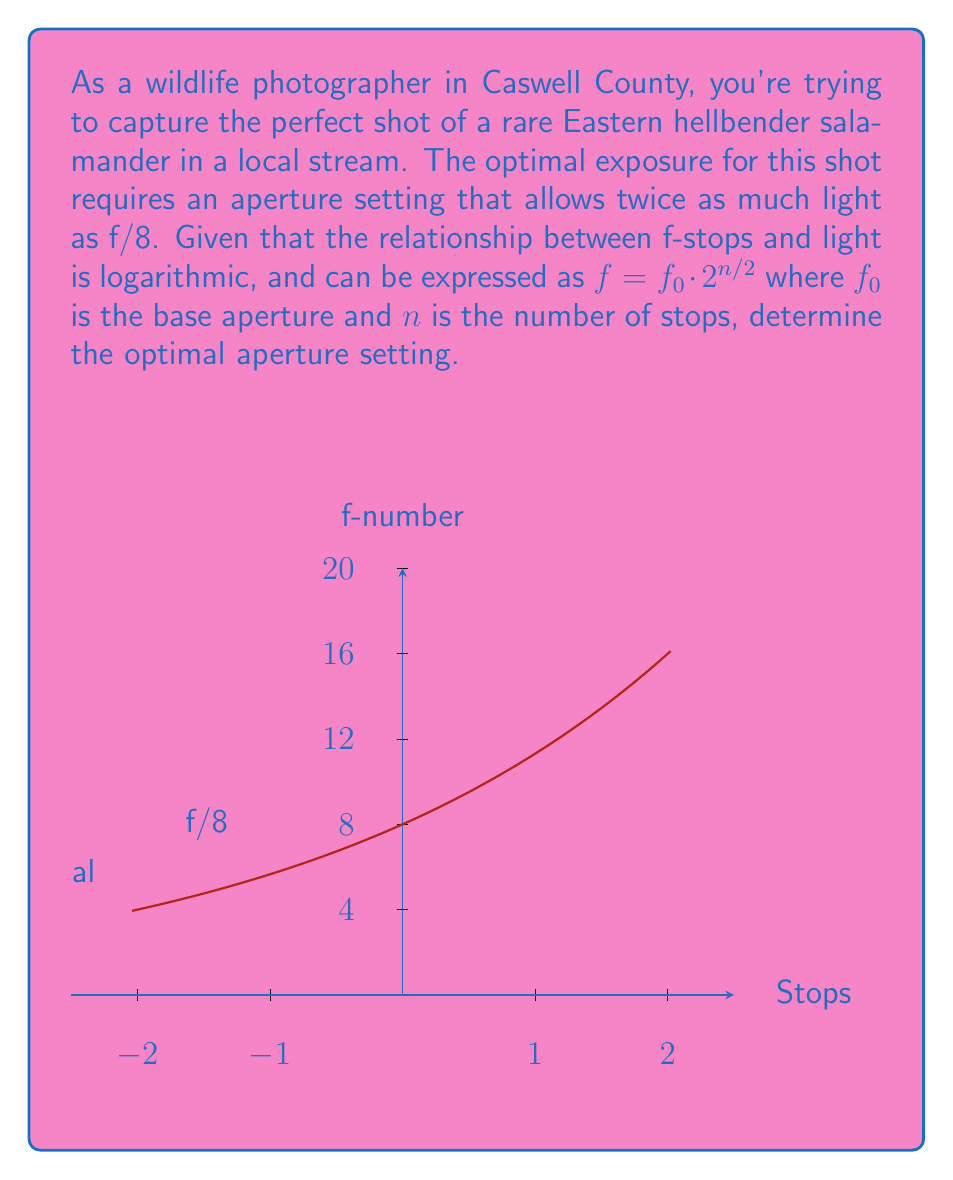Can you answer this question? Let's approach this step-by-step:

1) We start with the given logarithmic function for f-stops:
   $f = f_0 \cdot 2^{n/2}$

2) We know that f/8 is our reference point, so $f_0 = 8$.

3) We want an aperture that allows twice as much light. In photography, each full stop represents a doubling or halving of light. So, we need to go down one full stop.

4) To go down one stop, we use $n = -1$ in our equation:
   $f = 8 \cdot 2^{-1/2}$

5) Let's calculate this:
   $f = 8 \cdot \frac{1}{\sqrt{2}}$

6) Simplify:
   $f = \frac{8}{\sqrt{2}} = 8 \cdot \frac{\sqrt{2}}{2} = 4\sqrt{2}$

7) In photography, this is typically rounded to the nearest standard f-stop, which would be f/5.6.
Answer: f/5.6 